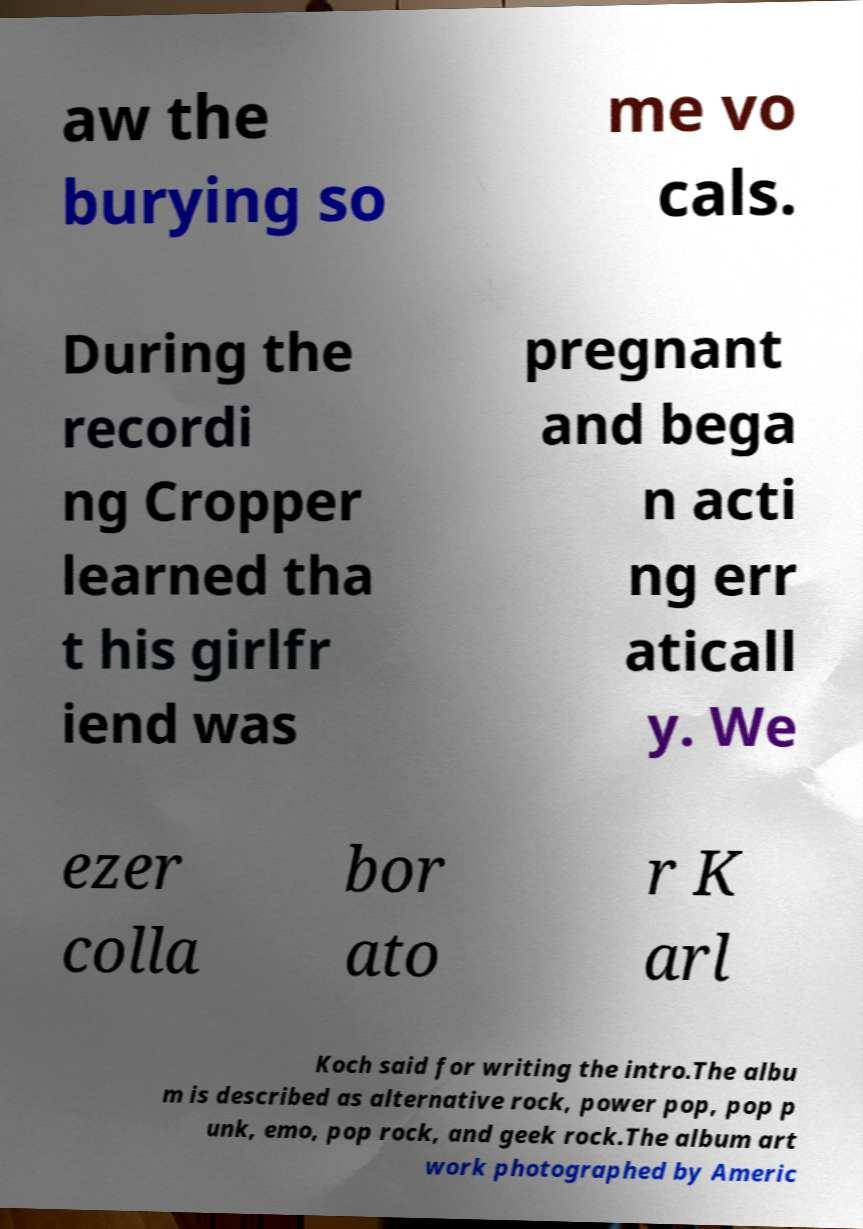For documentation purposes, I need the text within this image transcribed. Could you provide that? aw the burying so me vo cals. During the recordi ng Cropper learned tha t his girlfr iend was pregnant and bega n acti ng err aticall y. We ezer colla bor ato r K arl Koch said for writing the intro.The albu m is described as alternative rock, power pop, pop p unk, emo, pop rock, and geek rock.The album art work photographed by Americ 